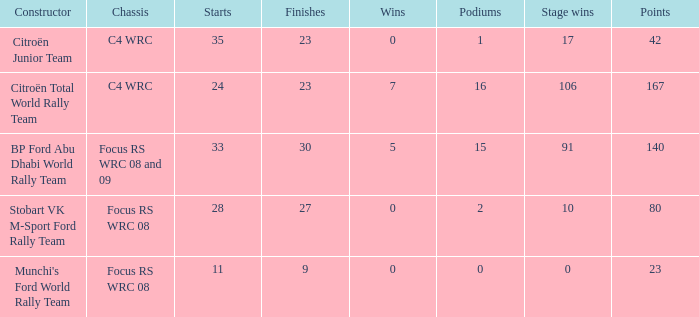What is the highest podiums when the stage wins is 91 and the points is less than 140? None. 